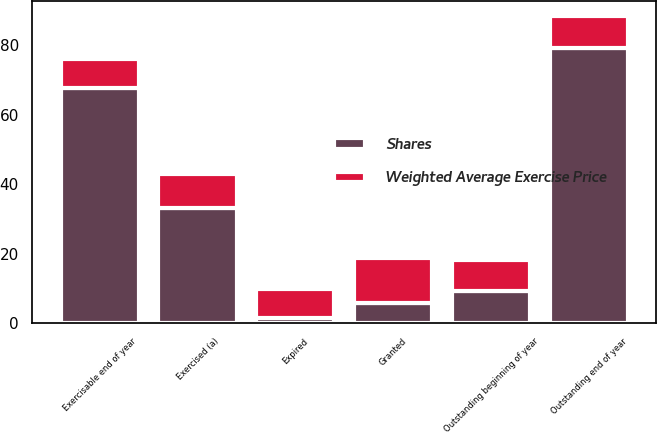Convert chart to OTSL. <chart><loc_0><loc_0><loc_500><loc_500><stacked_bar_chart><ecel><fcel>Outstanding beginning of year<fcel>Granted<fcel>Exercised (a)<fcel>Expired<fcel>Outstanding end of year<fcel>Exercisable end of year<nl><fcel>Shares<fcel>9.17<fcel>5.9<fcel>33.1<fcel>1.6<fcel>79.1<fcel>67.6<nl><fcel>Weighted Average Exercise Price<fcel>9.14<fcel>12.76<fcel>9.76<fcel>8.26<fcel>9.17<fcel>8.53<nl></chart> 